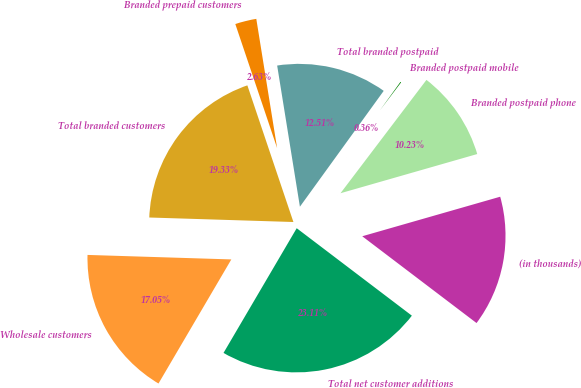<chart> <loc_0><loc_0><loc_500><loc_500><pie_chart><fcel>(in thousands)<fcel>Branded postpaid phone<fcel>Branded postpaid mobile<fcel>Total branded postpaid<fcel>Branded prepaid customers<fcel>Total branded customers<fcel>Wholesale customers<fcel>Total net customer additions<nl><fcel>14.78%<fcel>10.23%<fcel>0.36%<fcel>12.51%<fcel>2.63%<fcel>19.33%<fcel>17.05%<fcel>23.11%<nl></chart> 